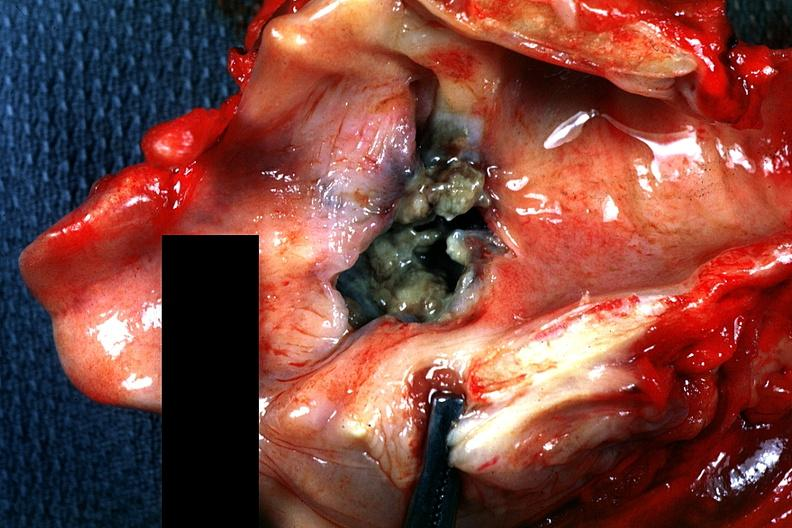s squamous cell carcinoma present?
Answer the question using a single word or phrase. Yes 